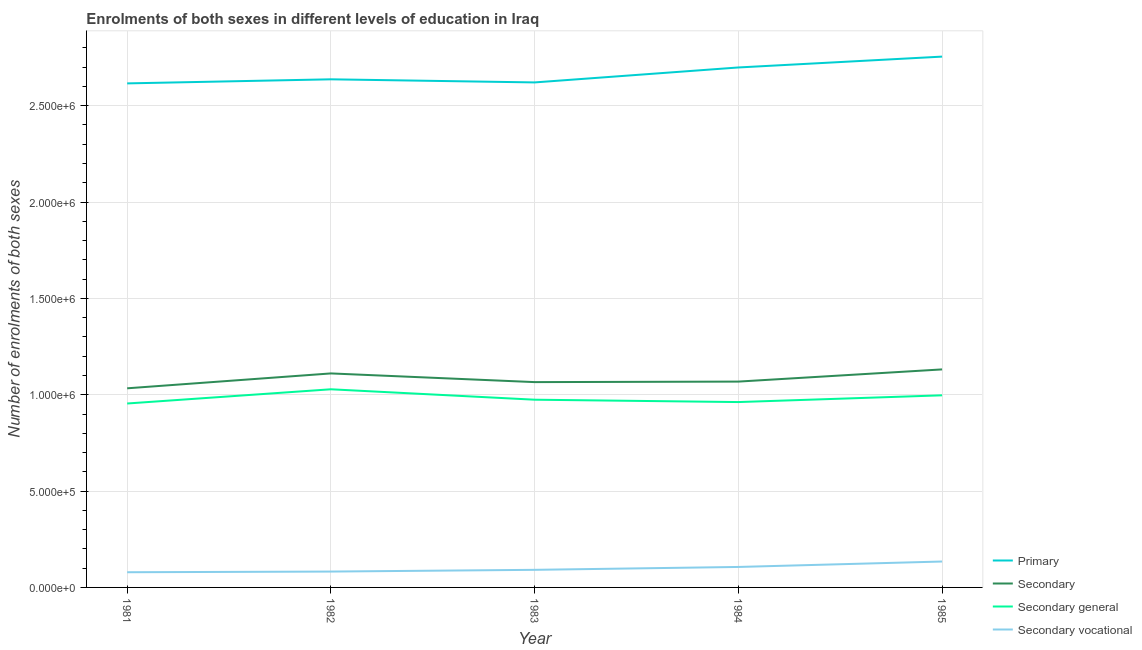How many different coloured lines are there?
Give a very brief answer. 4. Does the line corresponding to number of enrolments in secondary vocational education intersect with the line corresponding to number of enrolments in primary education?
Offer a very short reply. No. What is the number of enrolments in primary education in 1981?
Your answer should be very brief. 2.62e+06. Across all years, what is the maximum number of enrolments in secondary education?
Provide a succinct answer. 1.13e+06. Across all years, what is the minimum number of enrolments in secondary vocational education?
Give a very brief answer. 7.89e+04. In which year was the number of enrolments in secondary general education minimum?
Make the answer very short. 1981. What is the total number of enrolments in primary education in the graph?
Offer a terse response. 1.33e+07. What is the difference between the number of enrolments in secondary education in 1983 and that in 1984?
Your response must be concise. -2636. What is the difference between the number of enrolments in secondary general education in 1981 and the number of enrolments in secondary vocational education in 1982?
Your answer should be compact. 8.72e+05. What is the average number of enrolments in secondary general education per year?
Offer a very short reply. 9.83e+05. In the year 1984, what is the difference between the number of enrolments in primary education and number of enrolments in secondary general education?
Offer a very short reply. 1.74e+06. In how many years, is the number of enrolments in secondary vocational education greater than 600000?
Your answer should be very brief. 0. What is the ratio of the number of enrolments in secondary vocational education in 1981 to that in 1985?
Your answer should be very brief. 0.59. Is the number of enrolments in primary education in 1984 less than that in 1985?
Your answer should be compact. Yes. What is the difference between the highest and the second highest number of enrolments in secondary education?
Keep it short and to the point. 2.09e+04. What is the difference between the highest and the lowest number of enrolments in secondary vocational education?
Provide a succinct answer. 5.56e+04. In how many years, is the number of enrolments in secondary education greater than the average number of enrolments in secondary education taken over all years?
Give a very brief answer. 2. Is it the case that in every year, the sum of the number of enrolments in primary education and number of enrolments in secondary education is greater than the number of enrolments in secondary general education?
Your response must be concise. Yes. How many years are there in the graph?
Make the answer very short. 5. Are the values on the major ticks of Y-axis written in scientific E-notation?
Ensure brevity in your answer.  Yes. Does the graph contain any zero values?
Offer a terse response. No. Where does the legend appear in the graph?
Your answer should be very brief. Bottom right. What is the title of the graph?
Make the answer very short. Enrolments of both sexes in different levels of education in Iraq. Does "Social Insurance" appear as one of the legend labels in the graph?
Keep it short and to the point. No. What is the label or title of the X-axis?
Your answer should be very brief. Year. What is the label or title of the Y-axis?
Offer a terse response. Number of enrolments of both sexes. What is the Number of enrolments of both sexes in Primary in 1981?
Your answer should be very brief. 2.62e+06. What is the Number of enrolments of both sexes in Secondary in 1981?
Offer a very short reply. 1.03e+06. What is the Number of enrolments of both sexes of Secondary general in 1981?
Your answer should be compact. 9.55e+05. What is the Number of enrolments of both sexes of Secondary vocational in 1981?
Your answer should be compact. 7.89e+04. What is the Number of enrolments of both sexes of Primary in 1982?
Ensure brevity in your answer.  2.64e+06. What is the Number of enrolments of both sexes in Secondary in 1982?
Offer a terse response. 1.11e+06. What is the Number of enrolments of both sexes of Secondary general in 1982?
Ensure brevity in your answer.  1.03e+06. What is the Number of enrolments of both sexes in Secondary vocational in 1982?
Offer a terse response. 8.23e+04. What is the Number of enrolments of both sexes of Primary in 1983?
Give a very brief answer. 2.62e+06. What is the Number of enrolments of both sexes in Secondary in 1983?
Offer a very short reply. 1.07e+06. What is the Number of enrolments of both sexes in Secondary general in 1983?
Your answer should be very brief. 9.74e+05. What is the Number of enrolments of both sexes in Secondary vocational in 1983?
Ensure brevity in your answer.  9.13e+04. What is the Number of enrolments of both sexes in Primary in 1984?
Provide a short and direct response. 2.70e+06. What is the Number of enrolments of both sexes of Secondary in 1984?
Provide a short and direct response. 1.07e+06. What is the Number of enrolments of both sexes in Secondary general in 1984?
Make the answer very short. 9.62e+05. What is the Number of enrolments of both sexes of Secondary vocational in 1984?
Provide a succinct answer. 1.06e+05. What is the Number of enrolments of both sexes in Primary in 1985?
Give a very brief answer. 2.75e+06. What is the Number of enrolments of both sexes of Secondary in 1985?
Make the answer very short. 1.13e+06. What is the Number of enrolments of both sexes in Secondary general in 1985?
Your response must be concise. 9.97e+05. What is the Number of enrolments of both sexes in Secondary vocational in 1985?
Your response must be concise. 1.34e+05. Across all years, what is the maximum Number of enrolments of both sexes in Primary?
Your answer should be compact. 2.75e+06. Across all years, what is the maximum Number of enrolments of both sexes of Secondary?
Keep it short and to the point. 1.13e+06. Across all years, what is the maximum Number of enrolments of both sexes of Secondary general?
Your response must be concise. 1.03e+06. Across all years, what is the maximum Number of enrolments of both sexes of Secondary vocational?
Your answer should be compact. 1.34e+05. Across all years, what is the minimum Number of enrolments of both sexes in Primary?
Make the answer very short. 2.62e+06. Across all years, what is the minimum Number of enrolments of both sexes in Secondary?
Ensure brevity in your answer.  1.03e+06. Across all years, what is the minimum Number of enrolments of both sexes of Secondary general?
Give a very brief answer. 9.55e+05. Across all years, what is the minimum Number of enrolments of both sexes of Secondary vocational?
Provide a short and direct response. 7.89e+04. What is the total Number of enrolments of both sexes in Primary in the graph?
Offer a terse response. 1.33e+07. What is the total Number of enrolments of both sexes in Secondary in the graph?
Provide a succinct answer. 5.41e+06. What is the total Number of enrolments of both sexes of Secondary general in the graph?
Offer a very short reply. 4.92e+06. What is the total Number of enrolments of both sexes in Secondary vocational in the graph?
Your answer should be very brief. 4.93e+05. What is the difference between the Number of enrolments of both sexes in Primary in 1981 and that in 1982?
Provide a short and direct response. -2.11e+04. What is the difference between the Number of enrolments of both sexes in Secondary in 1981 and that in 1982?
Your answer should be very brief. -7.72e+04. What is the difference between the Number of enrolments of both sexes in Secondary general in 1981 and that in 1982?
Your answer should be very brief. -7.38e+04. What is the difference between the Number of enrolments of both sexes in Secondary vocational in 1981 and that in 1982?
Your answer should be very brief. -3425. What is the difference between the Number of enrolments of both sexes of Primary in 1981 and that in 1983?
Provide a short and direct response. -4973. What is the difference between the Number of enrolments of both sexes in Secondary in 1981 and that in 1983?
Your answer should be very brief. -3.22e+04. What is the difference between the Number of enrolments of both sexes in Secondary general in 1981 and that in 1983?
Provide a short and direct response. -1.97e+04. What is the difference between the Number of enrolments of both sexes of Secondary vocational in 1981 and that in 1983?
Provide a succinct answer. -1.25e+04. What is the difference between the Number of enrolments of both sexes of Primary in 1981 and that in 1984?
Provide a short and direct response. -8.26e+04. What is the difference between the Number of enrolments of both sexes in Secondary in 1981 and that in 1984?
Give a very brief answer. -3.48e+04. What is the difference between the Number of enrolments of both sexes of Secondary general in 1981 and that in 1984?
Make the answer very short. -7467. What is the difference between the Number of enrolments of both sexes of Secondary vocational in 1981 and that in 1984?
Provide a short and direct response. -2.73e+04. What is the difference between the Number of enrolments of both sexes in Primary in 1981 and that in 1985?
Offer a very short reply. -1.39e+05. What is the difference between the Number of enrolments of both sexes of Secondary in 1981 and that in 1985?
Keep it short and to the point. -9.81e+04. What is the difference between the Number of enrolments of both sexes of Secondary general in 1981 and that in 1985?
Offer a very short reply. -4.25e+04. What is the difference between the Number of enrolments of both sexes of Secondary vocational in 1981 and that in 1985?
Offer a very short reply. -5.56e+04. What is the difference between the Number of enrolments of both sexes in Primary in 1982 and that in 1983?
Ensure brevity in your answer.  1.61e+04. What is the difference between the Number of enrolments of both sexes in Secondary in 1982 and that in 1983?
Your answer should be very brief. 4.51e+04. What is the difference between the Number of enrolments of both sexes in Secondary general in 1982 and that in 1983?
Provide a succinct answer. 5.41e+04. What is the difference between the Number of enrolments of both sexes in Secondary vocational in 1982 and that in 1983?
Your answer should be compact. -9031. What is the difference between the Number of enrolments of both sexes of Primary in 1982 and that in 1984?
Give a very brief answer. -6.15e+04. What is the difference between the Number of enrolments of both sexes of Secondary in 1982 and that in 1984?
Your response must be concise. 4.24e+04. What is the difference between the Number of enrolments of both sexes of Secondary general in 1982 and that in 1984?
Make the answer very short. 6.63e+04. What is the difference between the Number of enrolments of both sexes of Secondary vocational in 1982 and that in 1984?
Make the answer very short. -2.39e+04. What is the difference between the Number of enrolments of both sexes of Primary in 1982 and that in 1985?
Provide a short and direct response. -1.18e+05. What is the difference between the Number of enrolments of both sexes of Secondary in 1982 and that in 1985?
Give a very brief answer. -2.09e+04. What is the difference between the Number of enrolments of both sexes in Secondary general in 1982 and that in 1985?
Provide a short and direct response. 3.13e+04. What is the difference between the Number of enrolments of both sexes in Secondary vocational in 1982 and that in 1985?
Offer a terse response. -5.21e+04. What is the difference between the Number of enrolments of both sexes in Primary in 1983 and that in 1984?
Make the answer very short. -7.77e+04. What is the difference between the Number of enrolments of both sexes of Secondary in 1983 and that in 1984?
Keep it short and to the point. -2636. What is the difference between the Number of enrolments of both sexes of Secondary general in 1983 and that in 1984?
Your answer should be compact. 1.22e+04. What is the difference between the Number of enrolments of both sexes of Secondary vocational in 1983 and that in 1984?
Ensure brevity in your answer.  -1.49e+04. What is the difference between the Number of enrolments of both sexes in Primary in 1983 and that in 1985?
Ensure brevity in your answer.  -1.34e+05. What is the difference between the Number of enrolments of both sexes of Secondary in 1983 and that in 1985?
Provide a succinct answer. -6.59e+04. What is the difference between the Number of enrolments of both sexes of Secondary general in 1983 and that in 1985?
Your answer should be very brief. -2.28e+04. What is the difference between the Number of enrolments of both sexes in Secondary vocational in 1983 and that in 1985?
Provide a short and direct response. -4.31e+04. What is the difference between the Number of enrolments of both sexes in Primary in 1984 and that in 1985?
Your answer should be compact. -5.63e+04. What is the difference between the Number of enrolments of both sexes in Secondary in 1984 and that in 1985?
Offer a very short reply. -6.33e+04. What is the difference between the Number of enrolments of both sexes of Secondary general in 1984 and that in 1985?
Offer a terse response. -3.51e+04. What is the difference between the Number of enrolments of both sexes of Secondary vocational in 1984 and that in 1985?
Your response must be concise. -2.82e+04. What is the difference between the Number of enrolments of both sexes in Primary in 1981 and the Number of enrolments of both sexes in Secondary in 1982?
Ensure brevity in your answer.  1.51e+06. What is the difference between the Number of enrolments of both sexes in Primary in 1981 and the Number of enrolments of both sexes in Secondary general in 1982?
Ensure brevity in your answer.  1.59e+06. What is the difference between the Number of enrolments of both sexes in Primary in 1981 and the Number of enrolments of both sexes in Secondary vocational in 1982?
Ensure brevity in your answer.  2.53e+06. What is the difference between the Number of enrolments of both sexes in Secondary in 1981 and the Number of enrolments of both sexes in Secondary general in 1982?
Give a very brief answer. 5070. What is the difference between the Number of enrolments of both sexes in Secondary in 1981 and the Number of enrolments of both sexes in Secondary vocational in 1982?
Keep it short and to the point. 9.51e+05. What is the difference between the Number of enrolments of both sexes of Secondary general in 1981 and the Number of enrolments of both sexes of Secondary vocational in 1982?
Give a very brief answer. 8.72e+05. What is the difference between the Number of enrolments of both sexes of Primary in 1981 and the Number of enrolments of both sexes of Secondary in 1983?
Your answer should be compact. 1.55e+06. What is the difference between the Number of enrolments of both sexes of Primary in 1981 and the Number of enrolments of both sexes of Secondary general in 1983?
Keep it short and to the point. 1.64e+06. What is the difference between the Number of enrolments of both sexes of Primary in 1981 and the Number of enrolments of both sexes of Secondary vocational in 1983?
Provide a short and direct response. 2.52e+06. What is the difference between the Number of enrolments of both sexes of Secondary in 1981 and the Number of enrolments of both sexes of Secondary general in 1983?
Provide a succinct answer. 5.92e+04. What is the difference between the Number of enrolments of both sexes of Secondary in 1981 and the Number of enrolments of both sexes of Secondary vocational in 1983?
Give a very brief answer. 9.42e+05. What is the difference between the Number of enrolments of both sexes of Secondary general in 1981 and the Number of enrolments of both sexes of Secondary vocational in 1983?
Give a very brief answer. 8.63e+05. What is the difference between the Number of enrolments of both sexes in Primary in 1981 and the Number of enrolments of both sexes in Secondary in 1984?
Ensure brevity in your answer.  1.55e+06. What is the difference between the Number of enrolments of both sexes in Primary in 1981 and the Number of enrolments of both sexes in Secondary general in 1984?
Keep it short and to the point. 1.65e+06. What is the difference between the Number of enrolments of both sexes in Primary in 1981 and the Number of enrolments of both sexes in Secondary vocational in 1984?
Offer a very short reply. 2.51e+06. What is the difference between the Number of enrolments of both sexes in Secondary in 1981 and the Number of enrolments of both sexes in Secondary general in 1984?
Make the answer very short. 7.14e+04. What is the difference between the Number of enrolments of both sexes in Secondary in 1981 and the Number of enrolments of both sexes in Secondary vocational in 1984?
Offer a terse response. 9.27e+05. What is the difference between the Number of enrolments of both sexes of Secondary general in 1981 and the Number of enrolments of both sexes of Secondary vocational in 1984?
Make the answer very short. 8.48e+05. What is the difference between the Number of enrolments of both sexes of Primary in 1981 and the Number of enrolments of both sexes of Secondary in 1985?
Your answer should be compact. 1.48e+06. What is the difference between the Number of enrolments of both sexes in Primary in 1981 and the Number of enrolments of both sexes in Secondary general in 1985?
Provide a short and direct response. 1.62e+06. What is the difference between the Number of enrolments of both sexes of Primary in 1981 and the Number of enrolments of both sexes of Secondary vocational in 1985?
Keep it short and to the point. 2.48e+06. What is the difference between the Number of enrolments of both sexes of Secondary in 1981 and the Number of enrolments of both sexes of Secondary general in 1985?
Ensure brevity in your answer.  3.63e+04. What is the difference between the Number of enrolments of both sexes in Secondary in 1981 and the Number of enrolments of both sexes in Secondary vocational in 1985?
Provide a short and direct response. 8.99e+05. What is the difference between the Number of enrolments of both sexes of Secondary general in 1981 and the Number of enrolments of both sexes of Secondary vocational in 1985?
Offer a very short reply. 8.20e+05. What is the difference between the Number of enrolments of both sexes in Primary in 1982 and the Number of enrolments of both sexes in Secondary in 1983?
Your answer should be compact. 1.57e+06. What is the difference between the Number of enrolments of both sexes in Primary in 1982 and the Number of enrolments of both sexes in Secondary general in 1983?
Your answer should be very brief. 1.66e+06. What is the difference between the Number of enrolments of both sexes in Primary in 1982 and the Number of enrolments of both sexes in Secondary vocational in 1983?
Offer a very short reply. 2.55e+06. What is the difference between the Number of enrolments of both sexes in Secondary in 1982 and the Number of enrolments of both sexes in Secondary general in 1983?
Your answer should be compact. 1.36e+05. What is the difference between the Number of enrolments of both sexes of Secondary in 1982 and the Number of enrolments of both sexes of Secondary vocational in 1983?
Your answer should be very brief. 1.02e+06. What is the difference between the Number of enrolments of both sexes of Secondary general in 1982 and the Number of enrolments of both sexes of Secondary vocational in 1983?
Ensure brevity in your answer.  9.37e+05. What is the difference between the Number of enrolments of both sexes in Primary in 1982 and the Number of enrolments of both sexes in Secondary in 1984?
Offer a very short reply. 1.57e+06. What is the difference between the Number of enrolments of both sexes in Primary in 1982 and the Number of enrolments of both sexes in Secondary general in 1984?
Ensure brevity in your answer.  1.68e+06. What is the difference between the Number of enrolments of both sexes in Primary in 1982 and the Number of enrolments of both sexes in Secondary vocational in 1984?
Provide a succinct answer. 2.53e+06. What is the difference between the Number of enrolments of both sexes in Secondary in 1982 and the Number of enrolments of both sexes in Secondary general in 1984?
Offer a terse response. 1.49e+05. What is the difference between the Number of enrolments of both sexes of Secondary in 1982 and the Number of enrolments of both sexes of Secondary vocational in 1984?
Your response must be concise. 1.00e+06. What is the difference between the Number of enrolments of both sexes in Secondary general in 1982 and the Number of enrolments of both sexes in Secondary vocational in 1984?
Offer a very short reply. 9.22e+05. What is the difference between the Number of enrolments of both sexes in Primary in 1982 and the Number of enrolments of both sexes in Secondary in 1985?
Give a very brief answer. 1.51e+06. What is the difference between the Number of enrolments of both sexes in Primary in 1982 and the Number of enrolments of both sexes in Secondary general in 1985?
Your answer should be very brief. 1.64e+06. What is the difference between the Number of enrolments of both sexes of Primary in 1982 and the Number of enrolments of both sexes of Secondary vocational in 1985?
Offer a very short reply. 2.50e+06. What is the difference between the Number of enrolments of both sexes of Secondary in 1982 and the Number of enrolments of both sexes of Secondary general in 1985?
Provide a succinct answer. 1.14e+05. What is the difference between the Number of enrolments of both sexes of Secondary in 1982 and the Number of enrolments of both sexes of Secondary vocational in 1985?
Keep it short and to the point. 9.76e+05. What is the difference between the Number of enrolments of both sexes in Secondary general in 1982 and the Number of enrolments of both sexes in Secondary vocational in 1985?
Keep it short and to the point. 8.94e+05. What is the difference between the Number of enrolments of both sexes in Primary in 1983 and the Number of enrolments of both sexes in Secondary in 1984?
Your answer should be compact. 1.55e+06. What is the difference between the Number of enrolments of both sexes in Primary in 1983 and the Number of enrolments of both sexes in Secondary general in 1984?
Provide a succinct answer. 1.66e+06. What is the difference between the Number of enrolments of both sexes of Primary in 1983 and the Number of enrolments of both sexes of Secondary vocational in 1984?
Offer a terse response. 2.51e+06. What is the difference between the Number of enrolments of both sexes of Secondary in 1983 and the Number of enrolments of both sexes of Secondary general in 1984?
Give a very brief answer. 1.04e+05. What is the difference between the Number of enrolments of both sexes in Secondary in 1983 and the Number of enrolments of both sexes in Secondary vocational in 1984?
Give a very brief answer. 9.59e+05. What is the difference between the Number of enrolments of both sexes in Secondary general in 1983 and the Number of enrolments of both sexes in Secondary vocational in 1984?
Offer a terse response. 8.68e+05. What is the difference between the Number of enrolments of both sexes in Primary in 1983 and the Number of enrolments of both sexes in Secondary in 1985?
Provide a short and direct response. 1.49e+06. What is the difference between the Number of enrolments of both sexes in Primary in 1983 and the Number of enrolments of both sexes in Secondary general in 1985?
Offer a terse response. 1.62e+06. What is the difference between the Number of enrolments of both sexes of Primary in 1983 and the Number of enrolments of both sexes of Secondary vocational in 1985?
Provide a short and direct response. 2.49e+06. What is the difference between the Number of enrolments of both sexes in Secondary in 1983 and the Number of enrolments of both sexes in Secondary general in 1985?
Give a very brief answer. 6.85e+04. What is the difference between the Number of enrolments of both sexes in Secondary in 1983 and the Number of enrolments of both sexes in Secondary vocational in 1985?
Make the answer very short. 9.31e+05. What is the difference between the Number of enrolments of both sexes in Secondary general in 1983 and the Number of enrolments of both sexes in Secondary vocational in 1985?
Provide a succinct answer. 8.40e+05. What is the difference between the Number of enrolments of both sexes of Primary in 1984 and the Number of enrolments of both sexes of Secondary in 1985?
Your response must be concise. 1.57e+06. What is the difference between the Number of enrolments of both sexes in Primary in 1984 and the Number of enrolments of both sexes in Secondary general in 1985?
Your response must be concise. 1.70e+06. What is the difference between the Number of enrolments of both sexes in Primary in 1984 and the Number of enrolments of both sexes in Secondary vocational in 1985?
Your answer should be compact. 2.56e+06. What is the difference between the Number of enrolments of both sexes of Secondary in 1984 and the Number of enrolments of both sexes of Secondary general in 1985?
Keep it short and to the point. 7.12e+04. What is the difference between the Number of enrolments of both sexes of Secondary in 1984 and the Number of enrolments of both sexes of Secondary vocational in 1985?
Offer a very short reply. 9.34e+05. What is the difference between the Number of enrolments of both sexes of Secondary general in 1984 and the Number of enrolments of both sexes of Secondary vocational in 1985?
Provide a succinct answer. 8.28e+05. What is the average Number of enrolments of both sexes in Primary per year?
Provide a short and direct response. 2.67e+06. What is the average Number of enrolments of both sexes of Secondary per year?
Keep it short and to the point. 1.08e+06. What is the average Number of enrolments of both sexes in Secondary general per year?
Offer a terse response. 9.83e+05. What is the average Number of enrolments of both sexes in Secondary vocational per year?
Give a very brief answer. 9.86e+04. In the year 1981, what is the difference between the Number of enrolments of both sexes of Primary and Number of enrolments of both sexes of Secondary?
Make the answer very short. 1.58e+06. In the year 1981, what is the difference between the Number of enrolments of both sexes in Primary and Number of enrolments of both sexes in Secondary general?
Give a very brief answer. 1.66e+06. In the year 1981, what is the difference between the Number of enrolments of both sexes in Primary and Number of enrolments of both sexes in Secondary vocational?
Ensure brevity in your answer.  2.54e+06. In the year 1981, what is the difference between the Number of enrolments of both sexes of Secondary and Number of enrolments of both sexes of Secondary general?
Provide a short and direct response. 7.89e+04. In the year 1981, what is the difference between the Number of enrolments of both sexes of Secondary and Number of enrolments of both sexes of Secondary vocational?
Provide a succinct answer. 9.55e+05. In the year 1981, what is the difference between the Number of enrolments of both sexes in Secondary general and Number of enrolments of both sexes in Secondary vocational?
Provide a succinct answer. 8.76e+05. In the year 1982, what is the difference between the Number of enrolments of both sexes of Primary and Number of enrolments of both sexes of Secondary?
Ensure brevity in your answer.  1.53e+06. In the year 1982, what is the difference between the Number of enrolments of both sexes in Primary and Number of enrolments of both sexes in Secondary general?
Offer a very short reply. 1.61e+06. In the year 1982, what is the difference between the Number of enrolments of both sexes of Primary and Number of enrolments of both sexes of Secondary vocational?
Your answer should be compact. 2.55e+06. In the year 1982, what is the difference between the Number of enrolments of both sexes in Secondary and Number of enrolments of both sexes in Secondary general?
Provide a succinct answer. 8.23e+04. In the year 1982, what is the difference between the Number of enrolments of both sexes of Secondary and Number of enrolments of both sexes of Secondary vocational?
Ensure brevity in your answer.  1.03e+06. In the year 1982, what is the difference between the Number of enrolments of both sexes of Secondary general and Number of enrolments of both sexes of Secondary vocational?
Your answer should be very brief. 9.46e+05. In the year 1983, what is the difference between the Number of enrolments of both sexes of Primary and Number of enrolments of both sexes of Secondary?
Your answer should be very brief. 1.56e+06. In the year 1983, what is the difference between the Number of enrolments of both sexes of Primary and Number of enrolments of both sexes of Secondary general?
Your response must be concise. 1.65e+06. In the year 1983, what is the difference between the Number of enrolments of both sexes in Primary and Number of enrolments of both sexes in Secondary vocational?
Your response must be concise. 2.53e+06. In the year 1983, what is the difference between the Number of enrolments of both sexes in Secondary and Number of enrolments of both sexes in Secondary general?
Offer a very short reply. 9.13e+04. In the year 1983, what is the difference between the Number of enrolments of both sexes of Secondary and Number of enrolments of both sexes of Secondary vocational?
Keep it short and to the point. 9.74e+05. In the year 1983, what is the difference between the Number of enrolments of both sexes in Secondary general and Number of enrolments of both sexes in Secondary vocational?
Provide a short and direct response. 8.83e+05. In the year 1984, what is the difference between the Number of enrolments of both sexes of Primary and Number of enrolments of both sexes of Secondary?
Offer a very short reply. 1.63e+06. In the year 1984, what is the difference between the Number of enrolments of both sexes in Primary and Number of enrolments of both sexes in Secondary general?
Your answer should be compact. 1.74e+06. In the year 1984, what is the difference between the Number of enrolments of both sexes of Primary and Number of enrolments of both sexes of Secondary vocational?
Provide a short and direct response. 2.59e+06. In the year 1984, what is the difference between the Number of enrolments of both sexes of Secondary and Number of enrolments of both sexes of Secondary general?
Offer a very short reply. 1.06e+05. In the year 1984, what is the difference between the Number of enrolments of both sexes in Secondary and Number of enrolments of both sexes in Secondary vocational?
Ensure brevity in your answer.  9.62e+05. In the year 1984, what is the difference between the Number of enrolments of both sexes in Secondary general and Number of enrolments of both sexes in Secondary vocational?
Give a very brief answer. 8.56e+05. In the year 1985, what is the difference between the Number of enrolments of both sexes in Primary and Number of enrolments of both sexes in Secondary?
Provide a short and direct response. 1.62e+06. In the year 1985, what is the difference between the Number of enrolments of both sexes of Primary and Number of enrolments of both sexes of Secondary general?
Provide a short and direct response. 1.76e+06. In the year 1985, what is the difference between the Number of enrolments of both sexes of Primary and Number of enrolments of both sexes of Secondary vocational?
Provide a succinct answer. 2.62e+06. In the year 1985, what is the difference between the Number of enrolments of both sexes of Secondary and Number of enrolments of both sexes of Secondary general?
Your answer should be very brief. 1.34e+05. In the year 1985, what is the difference between the Number of enrolments of both sexes in Secondary and Number of enrolments of both sexes in Secondary vocational?
Provide a succinct answer. 9.97e+05. In the year 1985, what is the difference between the Number of enrolments of both sexes of Secondary general and Number of enrolments of both sexes of Secondary vocational?
Your answer should be compact. 8.63e+05. What is the ratio of the Number of enrolments of both sexes in Primary in 1981 to that in 1982?
Make the answer very short. 0.99. What is the ratio of the Number of enrolments of both sexes of Secondary in 1981 to that in 1982?
Provide a succinct answer. 0.93. What is the ratio of the Number of enrolments of both sexes in Secondary general in 1981 to that in 1982?
Your response must be concise. 0.93. What is the ratio of the Number of enrolments of both sexes in Secondary vocational in 1981 to that in 1982?
Provide a short and direct response. 0.96. What is the ratio of the Number of enrolments of both sexes of Primary in 1981 to that in 1983?
Your answer should be very brief. 1. What is the ratio of the Number of enrolments of both sexes in Secondary in 1981 to that in 1983?
Provide a succinct answer. 0.97. What is the ratio of the Number of enrolments of both sexes in Secondary general in 1981 to that in 1983?
Provide a short and direct response. 0.98. What is the ratio of the Number of enrolments of both sexes in Secondary vocational in 1981 to that in 1983?
Provide a short and direct response. 0.86. What is the ratio of the Number of enrolments of both sexes of Primary in 1981 to that in 1984?
Keep it short and to the point. 0.97. What is the ratio of the Number of enrolments of both sexes in Secondary in 1981 to that in 1984?
Provide a short and direct response. 0.97. What is the ratio of the Number of enrolments of both sexes of Secondary general in 1981 to that in 1984?
Provide a short and direct response. 0.99. What is the ratio of the Number of enrolments of both sexes of Secondary vocational in 1981 to that in 1984?
Offer a very short reply. 0.74. What is the ratio of the Number of enrolments of both sexes in Primary in 1981 to that in 1985?
Offer a very short reply. 0.95. What is the ratio of the Number of enrolments of both sexes of Secondary in 1981 to that in 1985?
Offer a terse response. 0.91. What is the ratio of the Number of enrolments of both sexes in Secondary general in 1981 to that in 1985?
Your answer should be compact. 0.96. What is the ratio of the Number of enrolments of both sexes of Secondary vocational in 1981 to that in 1985?
Provide a succinct answer. 0.59. What is the ratio of the Number of enrolments of both sexes in Primary in 1982 to that in 1983?
Ensure brevity in your answer.  1.01. What is the ratio of the Number of enrolments of both sexes in Secondary in 1982 to that in 1983?
Provide a short and direct response. 1.04. What is the ratio of the Number of enrolments of both sexes of Secondary general in 1982 to that in 1983?
Provide a succinct answer. 1.06. What is the ratio of the Number of enrolments of both sexes of Secondary vocational in 1982 to that in 1983?
Your response must be concise. 0.9. What is the ratio of the Number of enrolments of both sexes in Primary in 1982 to that in 1984?
Make the answer very short. 0.98. What is the ratio of the Number of enrolments of both sexes in Secondary in 1982 to that in 1984?
Make the answer very short. 1.04. What is the ratio of the Number of enrolments of both sexes in Secondary general in 1982 to that in 1984?
Make the answer very short. 1.07. What is the ratio of the Number of enrolments of both sexes of Secondary vocational in 1982 to that in 1984?
Your answer should be compact. 0.77. What is the ratio of the Number of enrolments of both sexes in Primary in 1982 to that in 1985?
Ensure brevity in your answer.  0.96. What is the ratio of the Number of enrolments of both sexes of Secondary in 1982 to that in 1985?
Provide a short and direct response. 0.98. What is the ratio of the Number of enrolments of both sexes of Secondary general in 1982 to that in 1985?
Ensure brevity in your answer.  1.03. What is the ratio of the Number of enrolments of both sexes in Secondary vocational in 1982 to that in 1985?
Your answer should be very brief. 0.61. What is the ratio of the Number of enrolments of both sexes of Primary in 1983 to that in 1984?
Ensure brevity in your answer.  0.97. What is the ratio of the Number of enrolments of both sexes in Secondary in 1983 to that in 1984?
Offer a very short reply. 1. What is the ratio of the Number of enrolments of both sexes of Secondary general in 1983 to that in 1984?
Ensure brevity in your answer.  1.01. What is the ratio of the Number of enrolments of both sexes of Secondary vocational in 1983 to that in 1984?
Offer a terse response. 0.86. What is the ratio of the Number of enrolments of both sexes of Primary in 1983 to that in 1985?
Give a very brief answer. 0.95. What is the ratio of the Number of enrolments of both sexes of Secondary in 1983 to that in 1985?
Ensure brevity in your answer.  0.94. What is the ratio of the Number of enrolments of both sexes in Secondary general in 1983 to that in 1985?
Give a very brief answer. 0.98. What is the ratio of the Number of enrolments of both sexes in Secondary vocational in 1983 to that in 1985?
Offer a terse response. 0.68. What is the ratio of the Number of enrolments of both sexes in Primary in 1984 to that in 1985?
Ensure brevity in your answer.  0.98. What is the ratio of the Number of enrolments of both sexes in Secondary in 1984 to that in 1985?
Provide a succinct answer. 0.94. What is the ratio of the Number of enrolments of both sexes in Secondary general in 1984 to that in 1985?
Provide a succinct answer. 0.96. What is the ratio of the Number of enrolments of both sexes in Secondary vocational in 1984 to that in 1985?
Your response must be concise. 0.79. What is the difference between the highest and the second highest Number of enrolments of both sexes in Primary?
Your answer should be very brief. 5.63e+04. What is the difference between the highest and the second highest Number of enrolments of both sexes in Secondary?
Offer a terse response. 2.09e+04. What is the difference between the highest and the second highest Number of enrolments of both sexes in Secondary general?
Provide a succinct answer. 3.13e+04. What is the difference between the highest and the second highest Number of enrolments of both sexes in Secondary vocational?
Your response must be concise. 2.82e+04. What is the difference between the highest and the lowest Number of enrolments of both sexes in Primary?
Provide a short and direct response. 1.39e+05. What is the difference between the highest and the lowest Number of enrolments of both sexes of Secondary?
Give a very brief answer. 9.81e+04. What is the difference between the highest and the lowest Number of enrolments of both sexes of Secondary general?
Provide a succinct answer. 7.38e+04. What is the difference between the highest and the lowest Number of enrolments of both sexes in Secondary vocational?
Your answer should be compact. 5.56e+04. 